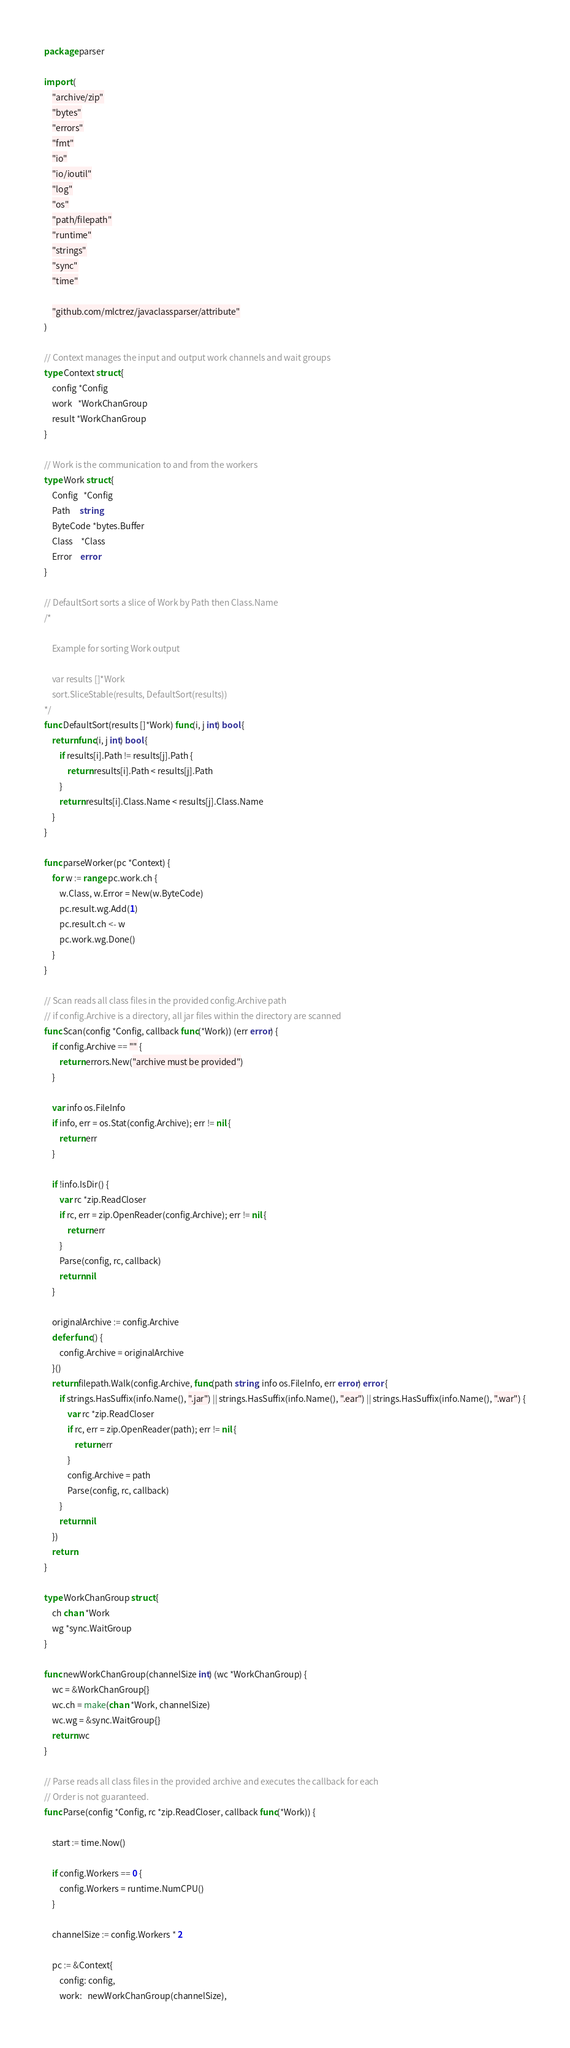Convert code to text. <code><loc_0><loc_0><loc_500><loc_500><_Go_>package parser

import (
	"archive/zip"
	"bytes"
	"errors"
	"fmt"
	"io"
	"io/ioutil"
	"log"
	"os"
	"path/filepath"
	"runtime"
	"strings"
	"sync"
	"time"

	"github.com/mlctrez/javaclassparser/attribute"
)

// Context manages the input and output work channels and wait groups
type Context struct {
	config *Config
	work   *WorkChanGroup
	result *WorkChanGroup
}

// Work is the communication to and from the workers
type Work struct {
	Config   *Config
	Path     string
	ByteCode *bytes.Buffer
	Class    *Class
	Error    error
}

// DefaultSort sorts a slice of Work by Path then Class.Name
/*

	Example for sorting Work output

	var results []*Work
	sort.SliceStable(results, DefaultSort(results))
*/
func DefaultSort(results []*Work) func(i, j int) bool {
	return func(i, j int) bool {
		if results[i].Path != results[j].Path {
			return results[i].Path < results[j].Path
		}
		return results[i].Class.Name < results[j].Class.Name
	}
}

func parseWorker(pc *Context) {
	for w := range pc.work.ch {
		w.Class, w.Error = New(w.ByteCode)
		pc.result.wg.Add(1)
		pc.result.ch <- w
		pc.work.wg.Done()
	}
}

// Scan reads all class files in the provided config.Archive path
// if config.Archive is a directory, all jar files within the directory are scanned
func Scan(config *Config, callback func(*Work)) (err error) {
	if config.Archive == "" {
		return errors.New("archive must be provided")
	}

	var info os.FileInfo
	if info, err = os.Stat(config.Archive); err != nil {
		return err
	}

	if !info.IsDir() {
		var rc *zip.ReadCloser
		if rc, err = zip.OpenReader(config.Archive); err != nil {
			return err
		}
		Parse(config, rc, callback)
		return nil
	}

	originalArchive := config.Archive
	defer func() {
		config.Archive = originalArchive
	}()
	return filepath.Walk(config.Archive, func(path string, info os.FileInfo, err error) error {
		if strings.HasSuffix(info.Name(), ".jar") || strings.HasSuffix(info.Name(), ".ear") || strings.HasSuffix(info.Name(), ".war") {
			var rc *zip.ReadCloser
			if rc, err = zip.OpenReader(path); err != nil {
				return err
			}
			config.Archive = path
			Parse(config, rc, callback)
		}
		return nil
	})
	return
}

type WorkChanGroup struct {
	ch chan *Work
	wg *sync.WaitGroup
}

func newWorkChanGroup(channelSize int) (wc *WorkChanGroup) {
	wc = &WorkChanGroup{}
	wc.ch = make(chan *Work, channelSize)
	wc.wg = &sync.WaitGroup{}
	return wc
}

// Parse reads all class files in the provided archive and executes the callback for each
// Order is not guaranteed.
func Parse(config *Config, rc *zip.ReadCloser, callback func(*Work)) {

	start := time.Now()

	if config.Workers == 0 {
		config.Workers = runtime.NumCPU()
	}

	channelSize := config.Workers * 2

	pc := &Context{
		config: config,
		work:   newWorkChanGroup(channelSize),</code> 